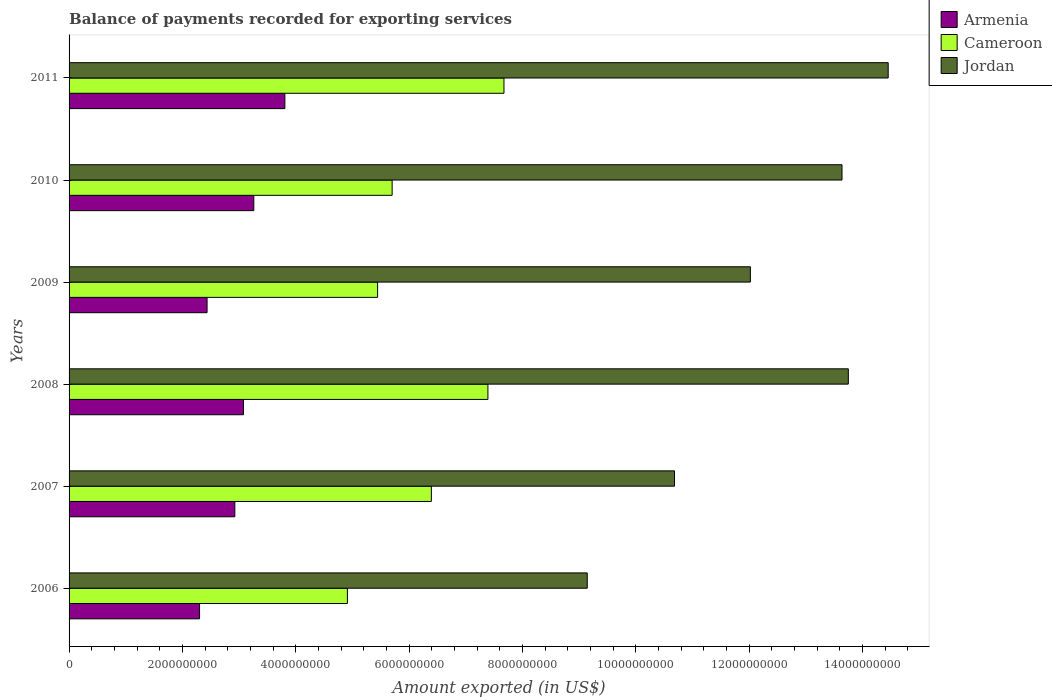How many groups of bars are there?
Provide a succinct answer. 6. Are the number of bars per tick equal to the number of legend labels?
Your answer should be compact. Yes. Are the number of bars on each tick of the Y-axis equal?
Offer a very short reply. Yes. In how many cases, is the number of bars for a given year not equal to the number of legend labels?
Offer a terse response. 0. What is the amount exported in Armenia in 2011?
Make the answer very short. 3.81e+09. Across all years, what is the maximum amount exported in Cameroon?
Keep it short and to the point. 7.67e+09. Across all years, what is the minimum amount exported in Cameroon?
Offer a terse response. 4.91e+09. In which year was the amount exported in Cameroon maximum?
Your answer should be compact. 2011. What is the total amount exported in Jordan in the graph?
Give a very brief answer. 7.37e+1. What is the difference between the amount exported in Armenia in 2006 and that in 2008?
Your response must be concise. -7.74e+08. What is the difference between the amount exported in Armenia in 2010 and the amount exported in Jordan in 2006?
Keep it short and to the point. -5.88e+09. What is the average amount exported in Jordan per year?
Offer a very short reply. 1.23e+1. In the year 2008, what is the difference between the amount exported in Armenia and amount exported in Cameroon?
Your response must be concise. -4.31e+09. What is the ratio of the amount exported in Jordan in 2010 to that in 2011?
Offer a very short reply. 0.94. Is the amount exported in Cameroon in 2008 less than that in 2009?
Provide a succinct answer. No. Is the difference between the amount exported in Armenia in 2008 and 2010 greater than the difference between the amount exported in Cameroon in 2008 and 2010?
Provide a succinct answer. No. What is the difference between the highest and the second highest amount exported in Jordan?
Provide a short and direct response. 7.04e+08. What is the difference between the highest and the lowest amount exported in Armenia?
Provide a succinct answer. 1.51e+09. In how many years, is the amount exported in Cameroon greater than the average amount exported in Cameroon taken over all years?
Provide a succinct answer. 3. What does the 3rd bar from the top in 2006 represents?
Provide a succinct answer. Armenia. What does the 3rd bar from the bottom in 2007 represents?
Provide a succinct answer. Jordan. How many bars are there?
Your answer should be compact. 18. What is the difference between two consecutive major ticks on the X-axis?
Offer a very short reply. 2.00e+09. Does the graph contain any zero values?
Provide a short and direct response. No. Where does the legend appear in the graph?
Provide a succinct answer. Top right. How many legend labels are there?
Make the answer very short. 3. How are the legend labels stacked?
Your answer should be very brief. Vertical. What is the title of the graph?
Your answer should be very brief. Balance of payments recorded for exporting services. What is the label or title of the X-axis?
Your response must be concise. Amount exported (in US$). What is the Amount exported (in US$) in Armenia in 2006?
Your answer should be very brief. 2.30e+09. What is the Amount exported (in US$) of Cameroon in 2006?
Your response must be concise. 4.91e+09. What is the Amount exported (in US$) of Jordan in 2006?
Provide a succinct answer. 9.14e+09. What is the Amount exported (in US$) in Armenia in 2007?
Provide a succinct answer. 2.92e+09. What is the Amount exported (in US$) of Cameroon in 2007?
Make the answer very short. 6.39e+09. What is the Amount exported (in US$) in Jordan in 2007?
Provide a succinct answer. 1.07e+1. What is the Amount exported (in US$) in Armenia in 2008?
Offer a terse response. 3.08e+09. What is the Amount exported (in US$) of Cameroon in 2008?
Your response must be concise. 7.39e+09. What is the Amount exported (in US$) of Jordan in 2008?
Provide a succinct answer. 1.38e+1. What is the Amount exported (in US$) in Armenia in 2009?
Your answer should be compact. 2.44e+09. What is the Amount exported (in US$) in Cameroon in 2009?
Your answer should be very brief. 5.44e+09. What is the Amount exported (in US$) of Jordan in 2009?
Offer a terse response. 1.20e+1. What is the Amount exported (in US$) in Armenia in 2010?
Your answer should be very brief. 3.26e+09. What is the Amount exported (in US$) of Cameroon in 2010?
Offer a very short reply. 5.70e+09. What is the Amount exported (in US$) of Jordan in 2010?
Offer a very short reply. 1.36e+1. What is the Amount exported (in US$) in Armenia in 2011?
Offer a terse response. 3.81e+09. What is the Amount exported (in US$) of Cameroon in 2011?
Your response must be concise. 7.67e+09. What is the Amount exported (in US$) in Jordan in 2011?
Your answer should be compact. 1.45e+1. Across all years, what is the maximum Amount exported (in US$) of Armenia?
Offer a very short reply. 3.81e+09. Across all years, what is the maximum Amount exported (in US$) of Cameroon?
Provide a short and direct response. 7.67e+09. Across all years, what is the maximum Amount exported (in US$) in Jordan?
Provide a succinct answer. 1.45e+1. Across all years, what is the minimum Amount exported (in US$) of Armenia?
Your response must be concise. 2.30e+09. Across all years, what is the minimum Amount exported (in US$) of Cameroon?
Give a very brief answer. 4.91e+09. Across all years, what is the minimum Amount exported (in US$) in Jordan?
Offer a terse response. 9.14e+09. What is the total Amount exported (in US$) of Armenia in the graph?
Your answer should be compact. 1.78e+1. What is the total Amount exported (in US$) in Cameroon in the graph?
Keep it short and to the point. 3.75e+1. What is the total Amount exported (in US$) in Jordan in the graph?
Your answer should be very brief. 7.37e+1. What is the difference between the Amount exported (in US$) in Armenia in 2006 and that in 2007?
Your response must be concise. -6.22e+08. What is the difference between the Amount exported (in US$) of Cameroon in 2006 and that in 2007?
Provide a short and direct response. -1.48e+09. What is the difference between the Amount exported (in US$) of Jordan in 2006 and that in 2007?
Your answer should be very brief. -1.54e+09. What is the difference between the Amount exported (in US$) of Armenia in 2006 and that in 2008?
Provide a succinct answer. -7.74e+08. What is the difference between the Amount exported (in US$) of Cameroon in 2006 and that in 2008?
Ensure brevity in your answer.  -2.48e+09. What is the difference between the Amount exported (in US$) of Jordan in 2006 and that in 2008?
Provide a succinct answer. -4.61e+09. What is the difference between the Amount exported (in US$) of Armenia in 2006 and that in 2009?
Offer a terse response. -1.32e+08. What is the difference between the Amount exported (in US$) of Cameroon in 2006 and that in 2009?
Provide a short and direct response. -5.33e+08. What is the difference between the Amount exported (in US$) in Jordan in 2006 and that in 2009?
Make the answer very short. -2.88e+09. What is the difference between the Amount exported (in US$) in Armenia in 2006 and that in 2010?
Your response must be concise. -9.57e+08. What is the difference between the Amount exported (in US$) in Cameroon in 2006 and that in 2010?
Offer a terse response. -7.89e+08. What is the difference between the Amount exported (in US$) of Jordan in 2006 and that in 2010?
Provide a short and direct response. -4.50e+09. What is the difference between the Amount exported (in US$) of Armenia in 2006 and that in 2011?
Your answer should be very brief. -1.51e+09. What is the difference between the Amount exported (in US$) in Cameroon in 2006 and that in 2011?
Provide a short and direct response. -2.76e+09. What is the difference between the Amount exported (in US$) in Jordan in 2006 and that in 2011?
Provide a short and direct response. -5.31e+09. What is the difference between the Amount exported (in US$) of Armenia in 2007 and that in 2008?
Your answer should be very brief. -1.52e+08. What is the difference between the Amount exported (in US$) of Cameroon in 2007 and that in 2008?
Give a very brief answer. -9.98e+08. What is the difference between the Amount exported (in US$) in Jordan in 2007 and that in 2008?
Provide a succinct answer. -3.07e+09. What is the difference between the Amount exported (in US$) of Armenia in 2007 and that in 2009?
Your answer should be compact. 4.90e+08. What is the difference between the Amount exported (in US$) in Cameroon in 2007 and that in 2009?
Your answer should be compact. 9.48e+08. What is the difference between the Amount exported (in US$) of Jordan in 2007 and that in 2009?
Offer a very short reply. -1.34e+09. What is the difference between the Amount exported (in US$) in Armenia in 2007 and that in 2010?
Give a very brief answer. -3.35e+08. What is the difference between the Amount exported (in US$) of Cameroon in 2007 and that in 2010?
Provide a short and direct response. 6.92e+08. What is the difference between the Amount exported (in US$) in Jordan in 2007 and that in 2010?
Your response must be concise. -2.96e+09. What is the difference between the Amount exported (in US$) in Armenia in 2007 and that in 2011?
Ensure brevity in your answer.  -8.83e+08. What is the difference between the Amount exported (in US$) in Cameroon in 2007 and that in 2011?
Make the answer very short. -1.28e+09. What is the difference between the Amount exported (in US$) in Jordan in 2007 and that in 2011?
Provide a succinct answer. -3.77e+09. What is the difference between the Amount exported (in US$) in Armenia in 2008 and that in 2009?
Your response must be concise. 6.42e+08. What is the difference between the Amount exported (in US$) of Cameroon in 2008 and that in 2009?
Offer a terse response. 1.95e+09. What is the difference between the Amount exported (in US$) of Jordan in 2008 and that in 2009?
Give a very brief answer. 1.73e+09. What is the difference between the Amount exported (in US$) in Armenia in 2008 and that in 2010?
Your answer should be compact. -1.83e+08. What is the difference between the Amount exported (in US$) of Cameroon in 2008 and that in 2010?
Ensure brevity in your answer.  1.69e+09. What is the difference between the Amount exported (in US$) of Jordan in 2008 and that in 2010?
Make the answer very short. 1.12e+08. What is the difference between the Amount exported (in US$) of Armenia in 2008 and that in 2011?
Offer a very short reply. -7.31e+08. What is the difference between the Amount exported (in US$) of Cameroon in 2008 and that in 2011?
Make the answer very short. -2.83e+08. What is the difference between the Amount exported (in US$) in Jordan in 2008 and that in 2011?
Provide a short and direct response. -7.04e+08. What is the difference between the Amount exported (in US$) of Armenia in 2009 and that in 2010?
Give a very brief answer. -8.25e+08. What is the difference between the Amount exported (in US$) of Cameroon in 2009 and that in 2010?
Offer a terse response. -2.56e+08. What is the difference between the Amount exported (in US$) in Jordan in 2009 and that in 2010?
Provide a short and direct response. -1.62e+09. What is the difference between the Amount exported (in US$) in Armenia in 2009 and that in 2011?
Your answer should be very brief. -1.37e+09. What is the difference between the Amount exported (in US$) in Cameroon in 2009 and that in 2011?
Offer a terse response. -2.23e+09. What is the difference between the Amount exported (in US$) in Jordan in 2009 and that in 2011?
Your answer should be very brief. -2.43e+09. What is the difference between the Amount exported (in US$) in Armenia in 2010 and that in 2011?
Provide a short and direct response. -5.48e+08. What is the difference between the Amount exported (in US$) of Cameroon in 2010 and that in 2011?
Give a very brief answer. -1.97e+09. What is the difference between the Amount exported (in US$) in Jordan in 2010 and that in 2011?
Offer a very short reply. -8.15e+08. What is the difference between the Amount exported (in US$) of Armenia in 2006 and the Amount exported (in US$) of Cameroon in 2007?
Your response must be concise. -4.09e+09. What is the difference between the Amount exported (in US$) of Armenia in 2006 and the Amount exported (in US$) of Jordan in 2007?
Ensure brevity in your answer.  -8.38e+09. What is the difference between the Amount exported (in US$) in Cameroon in 2006 and the Amount exported (in US$) in Jordan in 2007?
Keep it short and to the point. -5.77e+09. What is the difference between the Amount exported (in US$) in Armenia in 2006 and the Amount exported (in US$) in Cameroon in 2008?
Provide a short and direct response. -5.09e+09. What is the difference between the Amount exported (in US$) of Armenia in 2006 and the Amount exported (in US$) of Jordan in 2008?
Offer a terse response. -1.14e+1. What is the difference between the Amount exported (in US$) in Cameroon in 2006 and the Amount exported (in US$) in Jordan in 2008?
Make the answer very short. -8.84e+09. What is the difference between the Amount exported (in US$) of Armenia in 2006 and the Amount exported (in US$) of Cameroon in 2009?
Provide a short and direct response. -3.14e+09. What is the difference between the Amount exported (in US$) of Armenia in 2006 and the Amount exported (in US$) of Jordan in 2009?
Provide a succinct answer. -9.72e+09. What is the difference between the Amount exported (in US$) in Cameroon in 2006 and the Amount exported (in US$) in Jordan in 2009?
Keep it short and to the point. -7.11e+09. What is the difference between the Amount exported (in US$) of Armenia in 2006 and the Amount exported (in US$) of Cameroon in 2010?
Offer a very short reply. -3.40e+09. What is the difference between the Amount exported (in US$) in Armenia in 2006 and the Amount exported (in US$) in Jordan in 2010?
Ensure brevity in your answer.  -1.13e+1. What is the difference between the Amount exported (in US$) in Cameroon in 2006 and the Amount exported (in US$) in Jordan in 2010?
Make the answer very short. -8.73e+09. What is the difference between the Amount exported (in US$) in Armenia in 2006 and the Amount exported (in US$) in Cameroon in 2011?
Keep it short and to the point. -5.37e+09. What is the difference between the Amount exported (in US$) in Armenia in 2006 and the Amount exported (in US$) in Jordan in 2011?
Offer a very short reply. -1.22e+1. What is the difference between the Amount exported (in US$) of Cameroon in 2006 and the Amount exported (in US$) of Jordan in 2011?
Ensure brevity in your answer.  -9.54e+09. What is the difference between the Amount exported (in US$) of Armenia in 2007 and the Amount exported (in US$) of Cameroon in 2008?
Keep it short and to the point. -4.47e+09. What is the difference between the Amount exported (in US$) in Armenia in 2007 and the Amount exported (in US$) in Jordan in 2008?
Your answer should be very brief. -1.08e+1. What is the difference between the Amount exported (in US$) in Cameroon in 2007 and the Amount exported (in US$) in Jordan in 2008?
Your response must be concise. -7.36e+09. What is the difference between the Amount exported (in US$) of Armenia in 2007 and the Amount exported (in US$) of Cameroon in 2009?
Your answer should be compact. -2.52e+09. What is the difference between the Amount exported (in US$) in Armenia in 2007 and the Amount exported (in US$) in Jordan in 2009?
Offer a terse response. -9.10e+09. What is the difference between the Amount exported (in US$) in Cameroon in 2007 and the Amount exported (in US$) in Jordan in 2009?
Your answer should be very brief. -5.63e+09. What is the difference between the Amount exported (in US$) of Armenia in 2007 and the Amount exported (in US$) of Cameroon in 2010?
Offer a very short reply. -2.78e+09. What is the difference between the Amount exported (in US$) in Armenia in 2007 and the Amount exported (in US$) in Jordan in 2010?
Give a very brief answer. -1.07e+1. What is the difference between the Amount exported (in US$) of Cameroon in 2007 and the Amount exported (in US$) of Jordan in 2010?
Your answer should be very brief. -7.25e+09. What is the difference between the Amount exported (in US$) in Armenia in 2007 and the Amount exported (in US$) in Cameroon in 2011?
Keep it short and to the point. -4.75e+09. What is the difference between the Amount exported (in US$) of Armenia in 2007 and the Amount exported (in US$) of Jordan in 2011?
Offer a terse response. -1.15e+1. What is the difference between the Amount exported (in US$) in Cameroon in 2007 and the Amount exported (in US$) in Jordan in 2011?
Ensure brevity in your answer.  -8.06e+09. What is the difference between the Amount exported (in US$) of Armenia in 2008 and the Amount exported (in US$) of Cameroon in 2009?
Give a very brief answer. -2.37e+09. What is the difference between the Amount exported (in US$) of Armenia in 2008 and the Amount exported (in US$) of Jordan in 2009?
Keep it short and to the point. -8.95e+09. What is the difference between the Amount exported (in US$) of Cameroon in 2008 and the Amount exported (in US$) of Jordan in 2009?
Your answer should be very brief. -4.63e+09. What is the difference between the Amount exported (in US$) in Armenia in 2008 and the Amount exported (in US$) in Cameroon in 2010?
Provide a succinct answer. -2.62e+09. What is the difference between the Amount exported (in US$) of Armenia in 2008 and the Amount exported (in US$) of Jordan in 2010?
Your answer should be compact. -1.06e+1. What is the difference between the Amount exported (in US$) in Cameroon in 2008 and the Amount exported (in US$) in Jordan in 2010?
Your answer should be very brief. -6.25e+09. What is the difference between the Amount exported (in US$) in Armenia in 2008 and the Amount exported (in US$) in Cameroon in 2011?
Your answer should be compact. -4.60e+09. What is the difference between the Amount exported (in US$) in Armenia in 2008 and the Amount exported (in US$) in Jordan in 2011?
Give a very brief answer. -1.14e+1. What is the difference between the Amount exported (in US$) in Cameroon in 2008 and the Amount exported (in US$) in Jordan in 2011?
Your answer should be compact. -7.06e+09. What is the difference between the Amount exported (in US$) in Armenia in 2009 and the Amount exported (in US$) in Cameroon in 2010?
Provide a short and direct response. -3.27e+09. What is the difference between the Amount exported (in US$) of Armenia in 2009 and the Amount exported (in US$) of Jordan in 2010?
Give a very brief answer. -1.12e+1. What is the difference between the Amount exported (in US$) in Cameroon in 2009 and the Amount exported (in US$) in Jordan in 2010?
Keep it short and to the point. -8.19e+09. What is the difference between the Amount exported (in US$) of Armenia in 2009 and the Amount exported (in US$) of Cameroon in 2011?
Offer a very short reply. -5.24e+09. What is the difference between the Amount exported (in US$) of Armenia in 2009 and the Amount exported (in US$) of Jordan in 2011?
Offer a very short reply. -1.20e+1. What is the difference between the Amount exported (in US$) of Cameroon in 2009 and the Amount exported (in US$) of Jordan in 2011?
Offer a terse response. -9.01e+09. What is the difference between the Amount exported (in US$) of Armenia in 2010 and the Amount exported (in US$) of Cameroon in 2011?
Keep it short and to the point. -4.41e+09. What is the difference between the Amount exported (in US$) of Armenia in 2010 and the Amount exported (in US$) of Jordan in 2011?
Provide a succinct answer. -1.12e+1. What is the difference between the Amount exported (in US$) in Cameroon in 2010 and the Amount exported (in US$) in Jordan in 2011?
Give a very brief answer. -8.75e+09. What is the average Amount exported (in US$) in Armenia per year?
Offer a very short reply. 2.97e+09. What is the average Amount exported (in US$) of Cameroon per year?
Offer a terse response. 6.25e+09. What is the average Amount exported (in US$) in Jordan per year?
Your answer should be very brief. 1.23e+1. In the year 2006, what is the difference between the Amount exported (in US$) in Armenia and Amount exported (in US$) in Cameroon?
Make the answer very short. -2.61e+09. In the year 2006, what is the difference between the Amount exported (in US$) of Armenia and Amount exported (in US$) of Jordan?
Your answer should be compact. -6.84e+09. In the year 2006, what is the difference between the Amount exported (in US$) in Cameroon and Amount exported (in US$) in Jordan?
Your answer should be very brief. -4.23e+09. In the year 2007, what is the difference between the Amount exported (in US$) of Armenia and Amount exported (in US$) of Cameroon?
Make the answer very short. -3.47e+09. In the year 2007, what is the difference between the Amount exported (in US$) of Armenia and Amount exported (in US$) of Jordan?
Ensure brevity in your answer.  -7.76e+09. In the year 2007, what is the difference between the Amount exported (in US$) of Cameroon and Amount exported (in US$) of Jordan?
Your answer should be compact. -4.29e+09. In the year 2008, what is the difference between the Amount exported (in US$) in Armenia and Amount exported (in US$) in Cameroon?
Provide a short and direct response. -4.31e+09. In the year 2008, what is the difference between the Amount exported (in US$) of Armenia and Amount exported (in US$) of Jordan?
Offer a very short reply. -1.07e+1. In the year 2008, what is the difference between the Amount exported (in US$) of Cameroon and Amount exported (in US$) of Jordan?
Provide a succinct answer. -6.36e+09. In the year 2009, what is the difference between the Amount exported (in US$) of Armenia and Amount exported (in US$) of Cameroon?
Your response must be concise. -3.01e+09. In the year 2009, what is the difference between the Amount exported (in US$) of Armenia and Amount exported (in US$) of Jordan?
Provide a short and direct response. -9.59e+09. In the year 2009, what is the difference between the Amount exported (in US$) in Cameroon and Amount exported (in US$) in Jordan?
Give a very brief answer. -6.58e+09. In the year 2010, what is the difference between the Amount exported (in US$) of Armenia and Amount exported (in US$) of Cameroon?
Ensure brevity in your answer.  -2.44e+09. In the year 2010, what is the difference between the Amount exported (in US$) in Armenia and Amount exported (in US$) in Jordan?
Provide a succinct answer. -1.04e+1. In the year 2010, what is the difference between the Amount exported (in US$) of Cameroon and Amount exported (in US$) of Jordan?
Ensure brevity in your answer.  -7.94e+09. In the year 2011, what is the difference between the Amount exported (in US$) in Armenia and Amount exported (in US$) in Cameroon?
Offer a very short reply. -3.87e+09. In the year 2011, what is the difference between the Amount exported (in US$) in Armenia and Amount exported (in US$) in Jordan?
Provide a succinct answer. -1.06e+1. In the year 2011, what is the difference between the Amount exported (in US$) of Cameroon and Amount exported (in US$) of Jordan?
Your response must be concise. -6.78e+09. What is the ratio of the Amount exported (in US$) of Armenia in 2006 to that in 2007?
Your answer should be compact. 0.79. What is the ratio of the Amount exported (in US$) in Cameroon in 2006 to that in 2007?
Offer a very short reply. 0.77. What is the ratio of the Amount exported (in US$) of Jordan in 2006 to that in 2007?
Keep it short and to the point. 0.86. What is the ratio of the Amount exported (in US$) of Armenia in 2006 to that in 2008?
Keep it short and to the point. 0.75. What is the ratio of the Amount exported (in US$) of Cameroon in 2006 to that in 2008?
Make the answer very short. 0.66. What is the ratio of the Amount exported (in US$) in Jordan in 2006 to that in 2008?
Provide a short and direct response. 0.67. What is the ratio of the Amount exported (in US$) in Armenia in 2006 to that in 2009?
Keep it short and to the point. 0.95. What is the ratio of the Amount exported (in US$) in Cameroon in 2006 to that in 2009?
Your response must be concise. 0.9. What is the ratio of the Amount exported (in US$) in Jordan in 2006 to that in 2009?
Keep it short and to the point. 0.76. What is the ratio of the Amount exported (in US$) of Armenia in 2006 to that in 2010?
Give a very brief answer. 0.71. What is the ratio of the Amount exported (in US$) of Cameroon in 2006 to that in 2010?
Your answer should be very brief. 0.86. What is the ratio of the Amount exported (in US$) of Jordan in 2006 to that in 2010?
Offer a very short reply. 0.67. What is the ratio of the Amount exported (in US$) in Armenia in 2006 to that in 2011?
Keep it short and to the point. 0.6. What is the ratio of the Amount exported (in US$) in Cameroon in 2006 to that in 2011?
Your answer should be very brief. 0.64. What is the ratio of the Amount exported (in US$) in Jordan in 2006 to that in 2011?
Provide a short and direct response. 0.63. What is the ratio of the Amount exported (in US$) of Armenia in 2007 to that in 2008?
Give a very brief answer. 0.95. What is the ratio of the Amount exported (in US$) of Cameroon in 2007 to that in 2008?
Give a very brief answer. 0.86. What is the ratio of the Amount exported (in US$) in Jordan in 2007 to that in 2008?
Your answer should be very brief. 0.78. What is the ratio of the Amount exported (in US$) in Armenia in 2007 to that in 2009?
Give a very brief answer. 1.2. What is the ratio of the Amount exported (in US$) of Cameroon in 2007 to that in 2009?
Your response must be concise. 1.17. What is the ratio of the Amount exported (in US$) in Jordan in 2007 to that in 2009?
Provide a succinct answer. 0.89. What is the ratio of the Amount exported (in US$) in Armenia in 2007 to that in 2010?
Make the answer very short. 0.9. What is the ratio of the Amount exported (in US$) in Cameroon in 2007 to that in 2010?
Your response must be concise. 1.12. What is the ratio of the Amount exported (in US$) in Jordan in 2007 to that in 2010?
Provide a short and direct response. 0.78. What is the ratio of the Amount exported (in US$) of Armenia in 2007 to that in 2011?
Offer a terse response. 0.77. What is the ratio of the Amount exported (in US$) in Cameroon in 2007 to that in 2011?
Make the answer very short. 0.83. What is the ratio of the Amount exported (in US$) of Jordan in 2007 to that in 2011?
Offer a terse response. 0.74. What is the ratio of the Amount exported (in US$) in Armenia in 2008 to that in 2009?
Keep it short and to the point. 1.26. What is the ratio of the Amount exported (in US$) in Cameroon in 2008 to that in 2009?
Offer a terse response. 1.36. What is the ratio of the Amount exported (in US$) in Jordan in 2008 to that in 2009?
Offer a terse response. 1.14. What is the ratio of the Amount exported (in US$) in Armenia in 2008 to that in 2010?
Offer a terse response. 0.94. What is the ratio of the Amount exported (in US$) in Cameroon in 2008 to that in 2010?
Provide a succinct answer. 1.3. What is the ratio of the Amount exported (in US$) in Jordan in 2008 to that in 2010?
Your answer should be very brief. 1.01. What is the ratio of the Amount exported (in US$) of Armenia in 2008 to that in 2011?
Make the answer very short. 0.81. What is the ratio of the Amount exported (in US$) in Cameroon in 2008 to that in 2011?
Offer a terse response. 0.96. What is the ratio of the Amount exported (in US$) in Jordan in 2008 to that in 2011?
Ensure brevity in your answer.  0.95. What is the ratio of the Amount exported (in US$) of Armenia in 2009 to that in 2010?
Make the answer very short. 0.75. What is the ratio of the Amount exported (in US$) in Cameroon in 2009 to that in 2010?
Offer a terse response. 0.96. What is the ratio of the Amount exported (in US$) in Jordan in 2009 to that in 2010?
Keep it short and to the point. 0.88. What is the ratio of the Amount exported (in US$) in Armenia in 2009 to that in 2011?
Your answer should be very brief. 0.64. What is the ratio of the Amount exported (in US$) in Cameroon in 2009 to that in 2011?
Provide a short and direct response. 0.71. What is the ratio of the Amount exported (in US$) in Jordan in 2009 to that in 2011?
Keep it short and to the point. 0.83. What is the ratio of the Amount exported (in US$) of Armenia in 2010 to that in 2011?
Provide a succinct answer. 0.86. What is the ratio of the Amount exported (in US$) of Cameroon in 2010 to that in 2011?
Ensure brevity in your answer.  0.74. What is the ratio of the Amount exported (in US$) of Jordan in 2010 to that in 2011?
Provide a succinct answer. 0.94. What is the difference between the highest and the second highest Amount exported (in US$) of Armenia?
Make the answer very short. 5.48e+08. What is the difference between the highest and the second highest Amount exported (in US$) in Cameroon?
Your answer should be very brief. 2.83e+08. What is the difference between the highest and the second highest Amount exported (in US$) of Jordan?
Give a very brief answer. 7.04e+08. What is the difference between the highest and the lowest Amount exported (in US$) in Armenia?
Provide a short and direct response. 1.51e+09. What is the difference between the highest and the lowest Amount exported (in US$) in Cameroon?
Make the answer very short. 2.76e+09. What is the difference between the highest and the lowest Amount exported (in US$) of Jordan?
Ensure brevity in your answer.  5.31e+09. 